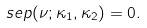<formula> <loc_0><loc_0><loc_500><loc_500>\ s e p ( \nu ; \kappa _ { 1 } , \kappa _ { 2 } ) = 0 .</formula> 